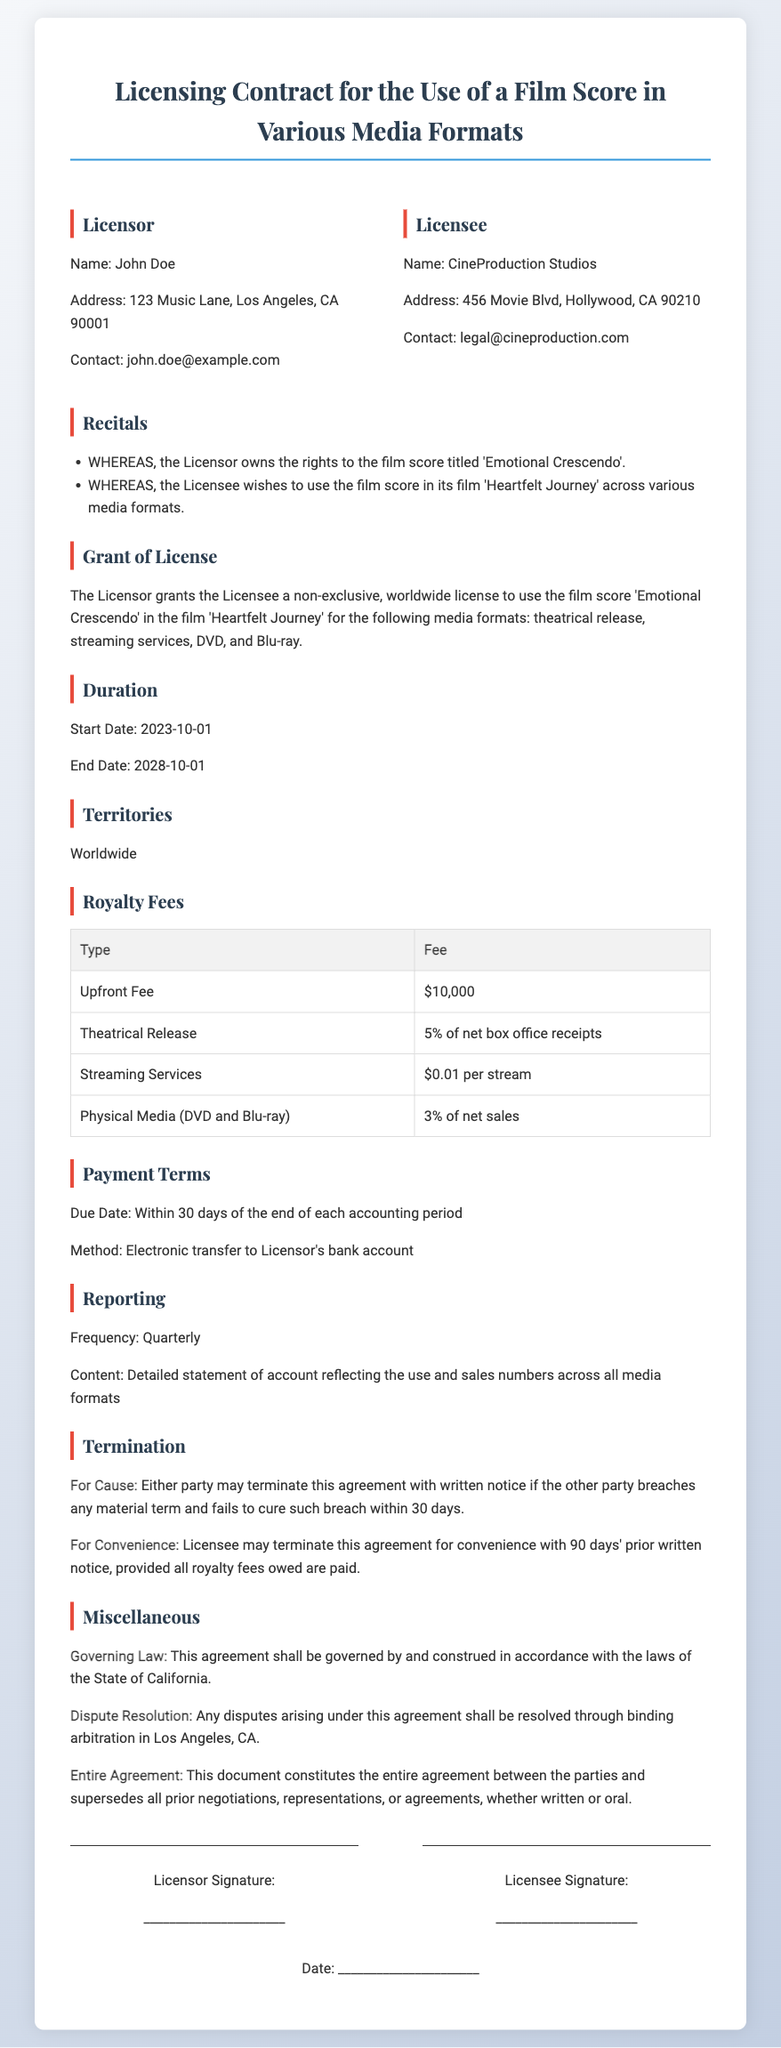What is the name of the Licensor? The Licensor's name is specified in the document as the person who owns the rights to the film score.
Answer: John Doe What is the title of the film score? The title of the film score that is being licensed is mentioned in the document.
Answer: Emotional Crescendo What is the royalty fee for the theatrical release? The document specifies a percentage of the net box office receipts for the theatrical release.
Answer: 5% of net box office receipts What is the start date of the license? The start date for the licensing agreement is provided in the document under the duration section.
Answer: 2023-10-01 How long is the duration of the contract? The duration of the contract is determined by the end date minus the start date as indicated in the document.
Answer: 5 years What method of payment is specified? The method of payment for the royalty fees is outlined in the payment terms section of the document.
Answer: Electronic transfer What is the governing law for the agreement? The document specifies which state's law will govern the contract in the miscellaneous section.
Answer: California What is the frequency of reporting? The frequency with which the Licensee must report back to the Licensor is stated in the reporting section.
Answer: Quarterly What type of contract is this document? The nature of the document is indicated in the title and recognized in the context.
Answer: Licensing Contract 